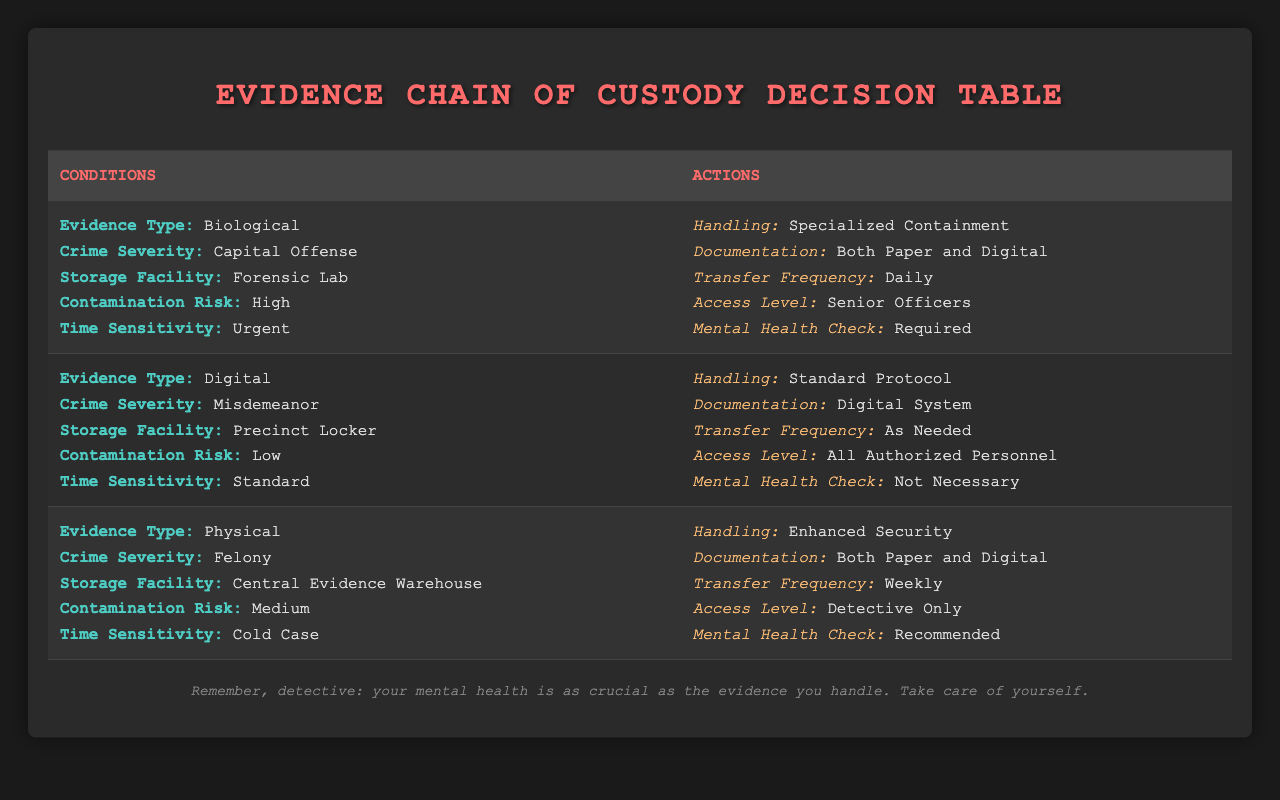What handling procedure is required for biological evidence in a capital offense case? The table indicates that for biological evidence linked to a capital offense, the handling procedure is "Specialized Containment." This is a direct retrieval from the relevant row in the table.
Answer: Specialized Containment Is documentation through both paper and digital systems necessary for misdemeanor cases? No, the table specifies that for digital evidence and misdemeanor cases, the documentation method is a "Digital System," indicating that both methods are not necessary.
Answer: No How often should evidence be transferred when handling physical evidence related to a felony? The table states that for physical evidence classified under felony, the transfer frequency is "Weekly." Thus, this is a clear retrieval from the associated row in the table.
Answer: Weekly Do all authorized personnel have access to biological evidence in urgent cases? No, the table specifies that access to biological evidence in urgent cases is limited to "Senior Officers." This can be confirmed by looking at the access level mentioned in the corresponding row.
Answer: No What is the mental health check requirement for digital evidence associated with misdemeanors? The table indicates that for digital evidence in misdemeanor cases, a mental health check is noted as "Not Necessary." This can be deduced directly from the relevant row in the table.
Answer: Not Necessary Which storage facility is designated for biological evidence in urgent capital offense cases? The table identifies that for biological evidence tied to capital offenses with urgent time sensitivity, the storage facility is designated as "Forensic Lab." This was gathered from analyzing the conditions specified in that row.
Answer: Forensic Lab If the evidence is physical and categorized under a felony, what is the contamination risk level assigned? The contamination risk level for physical evidence related to a felony is classified as "Medium," according to the information laid out in that specific row of the table.
Answer: Medium What would be the access level granted for physical evidence in cold cases? The table shows that for physical evidence classified as a cold case, the access level is restricted to "Detective Only." This can be derived from the actions linked to the conditions for that evidence.
Answer: Detective Only For urgent biological evidence, how frequently should evidence be transferred, and what documentation method is used? The table states that for urgent biological evidence, the transfer frequency is "Daily" and the documentation method is "Both Paper and Digital." This requires checking the corresponding data for those conditions.
Answer: Daily, Both Paper and Digital 